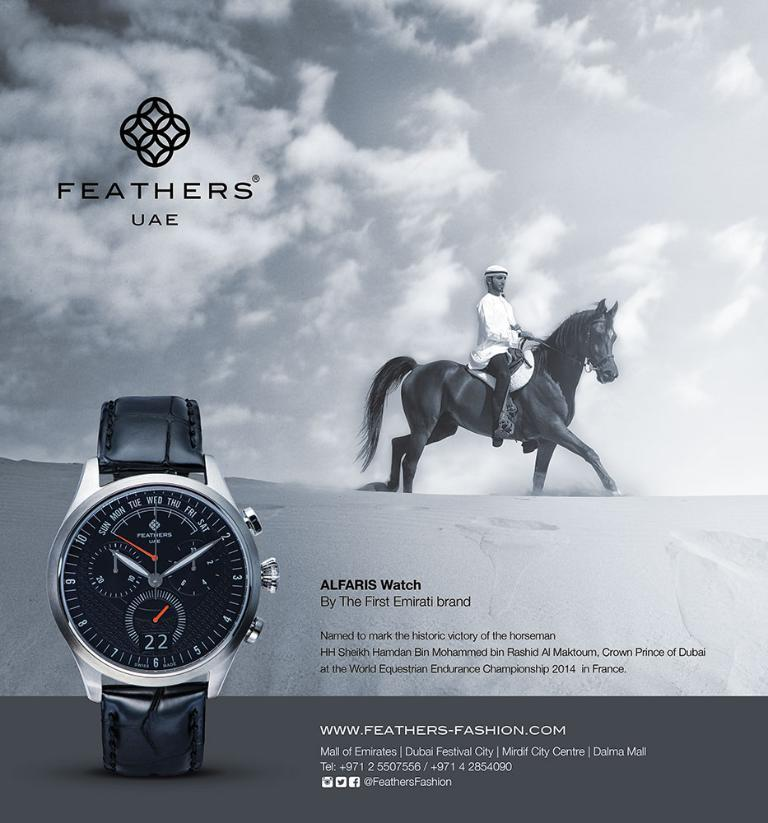<image>
Create a compact narrative representing the image presented. An Alfaris watch advertisement features a horseback rider. 